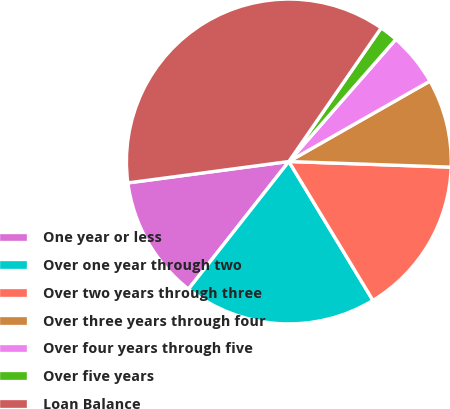Convert chart to OTSL. <chart><loc_0><loc_0><loc_500><loc_500><pie_chart><fcel>One year or less<fcel>Over one year through two<fcel>Over two years through three<fcel>Over three years through four<fcel>Over four years through five<fcel>Over five years<fcel>Loan Balance<nl><fcel>12.29%<fcel>19.27%<fcel>15.78%<fcel>8.8%<fcel>5.31%<fcel>1.82%<fcel>36.73%<nl></chart> 